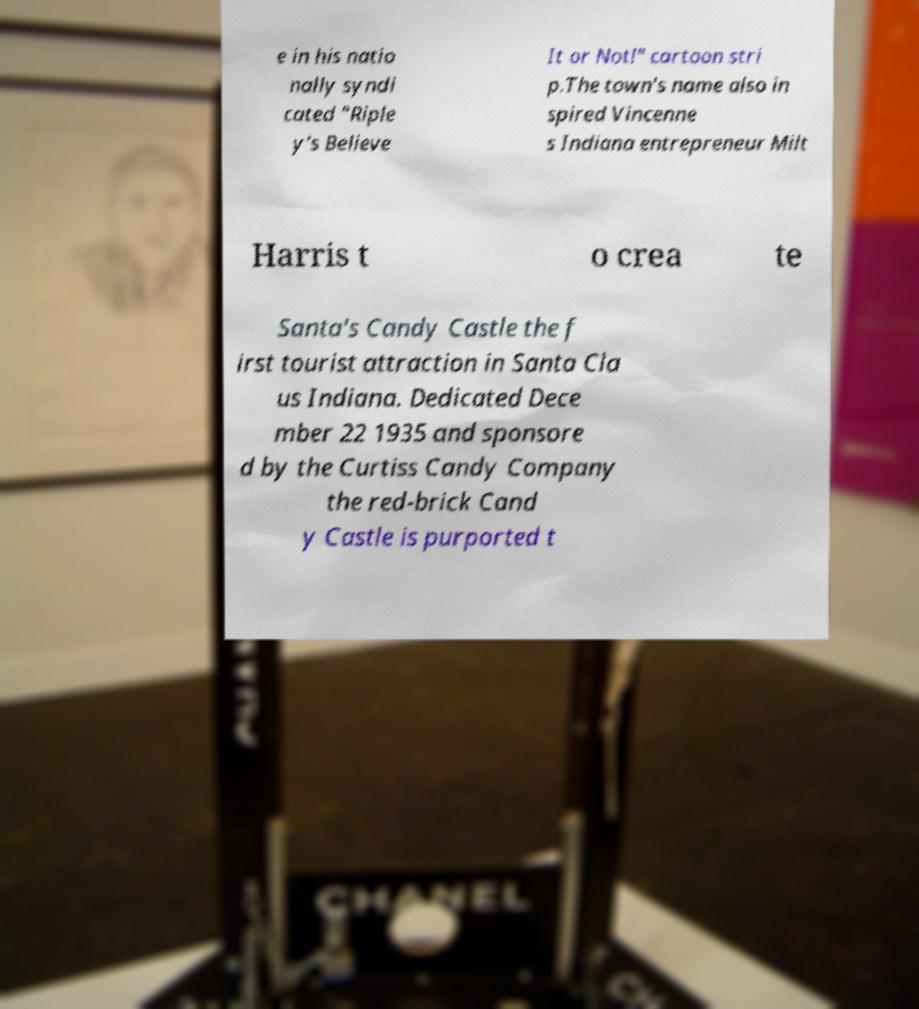For documentation purposes, I need the text within this image transcribed. Could you provide that? e in his natio nally syndi cated "Riple y's Believe It or Not!" cartoon stri p.The town's name also in spired Vincenne s Indiana entrepreneur Milt Harris t o crea te Santa's Candy Castle the f irst tourist attraction in Santa Cla us Indiana. Dedicated Dece mber 22 1935 and sponsore d by the Curtiss Candy Company the red-brick Cand y Castle is purported t 